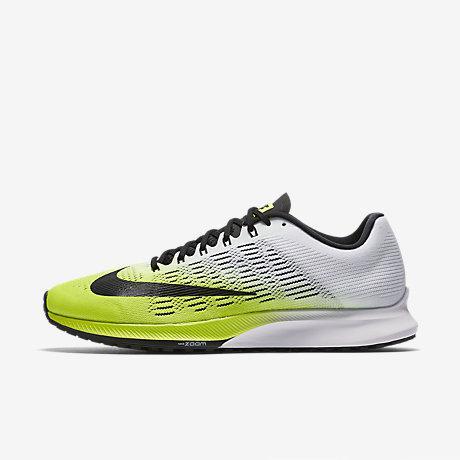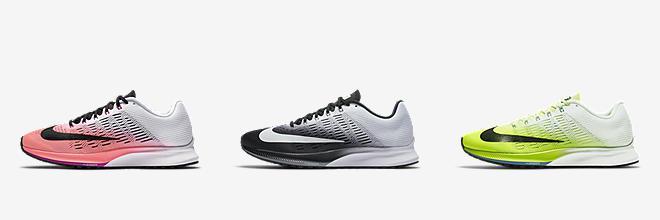The first image is the image on the left, the second image is the image on the right. Examine the images to the left and right. Is the description "Three shoe color options are shown in one image." accurate? Answer yes or no. Yes. 